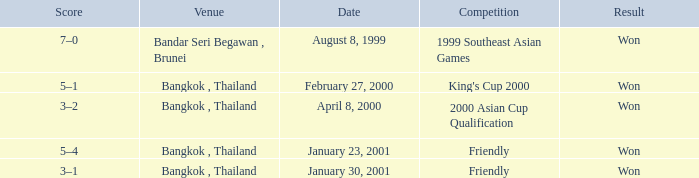What was the result from the 2000 asian cup qualification? Won. 